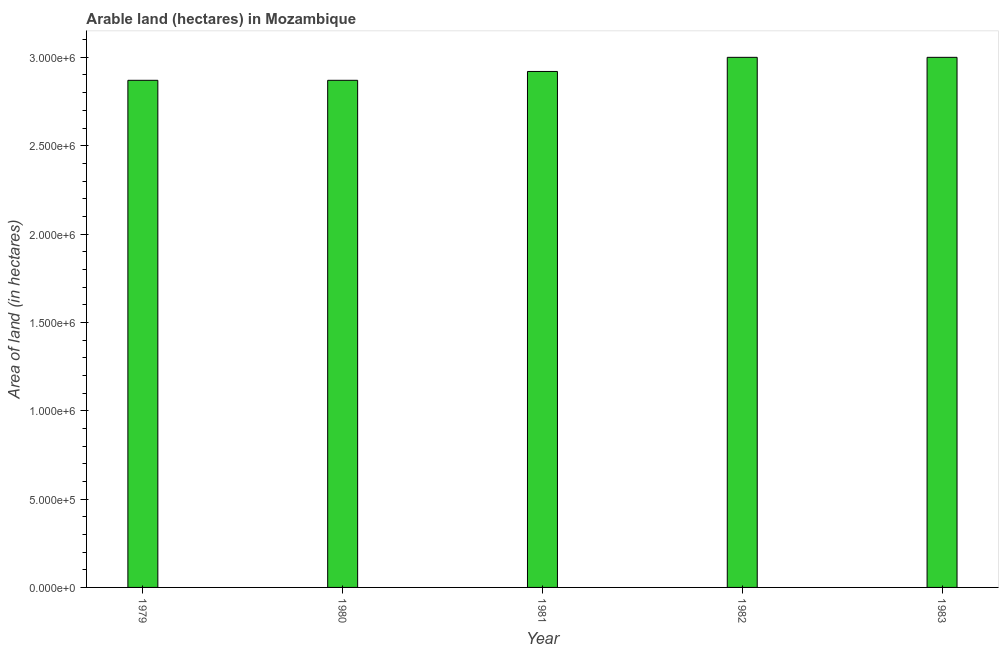Does the graph contain any zero values?
Give a very brief answer. No. Does the graph contain grids?
Provide a succinct answer. No. What is the title of the graph?
Ensure brevity in your answer.  Arable land (hectares) in Mozambique. What is the label or title of the Y-axis?
Provide a succinct answer. Area of land (in hectares). What is the area of land in 1979?
Keep it short and to the point. 2.87e+06. Across all years, what is the minimum area of land?
Keep it short and to the point. 2.87e+06. In which year was the area of land minimum?
Ensure brevity in your answer.  1979. What is the sum of the area of land?
Provide a short and direct response. 1.47e+07. What is the difference between the area of land in 1979 and 1981?
Your answer should be very brief. -5.00e+04. What is the average area of land per year?
Your response must be concise. 2.93e+06. What is the median area of land?
Your response must be concise. 2.92e+06. What is the ratio of the area of land in 1980 to that in 1982?
Keep it short and to the point. 0.96. Is the area of land in 1980 less than that in 1983?
Make the answer very short. Yes. Is the difference between the area of land in 1981 and 1983 greater than the difference between any two years?
Offer a very short reply. No. What is the difference between the highest and the second highest area of land?
Make the answer very short. 0. Is the sum of the area of land in 1979 and 1982 greater than the maximum area of land across all years?
Offer a terse response. Yes. In how many years, is the area of land greater than the average area of land taken over all years?
Give a very brief answer. 2. How many bars are there?
Give a very brief answer. 5. Are all the bars in the graph horizontal?
Provide a short and direct response. No. What is the difference between two consecutive major ticks on the Y-axis?
Keep it short and to the point. 5.00e+05. What is the Area of land (in hectares) in 1979?
Provide a short and direct response. 2.87e+06. What is the Area of land (in hectares) in 1980?
Your response must be concise. 2.87e+06. What is the Area of land (in hectares) of 1981?
Offer a terse response. 2.92e+06. What is the difference between the Area of land (in hectares) in 1979 and 1982?
Give a very brief answer. -1.30e+05. What is the difference between the Area of land (in hectares) in 1979 and 1983?
Make the answer very short. -1.30e+05. What is the difference between the Area of land (in hectares) in 1980 and 1982?
Keep it short and to the point. -1.30e+05. What is the difference between the Area of land (in hectares) in 1981 and 1982?
Offer a very short reply. -8.00e+04. What is the difference between the Area of land (in hectares) in 1982 and 1983?
Provide a succinct answer. 0. What is the ratio of the Area of land (in hectares) in 1979 to that in 1980?
Your answer should be very brief. 1. What is the ratio of the Area of land (in hectares) in 1979 to that in 1981?
Your response must be concise. 0.98. What is the ratio of the Area of land (in hectares) in 1979 to that in 1983?
Provide a succinct answer. 0.96. What is the ratio of the Area of land (in hectares) in 1980 to that in 1983?
Provide a succinct answer. 0.96. What is the ratio of the Area of land (in hectares) in 1982 to that in 1983?
Ensure brevity in your answer.  1. 